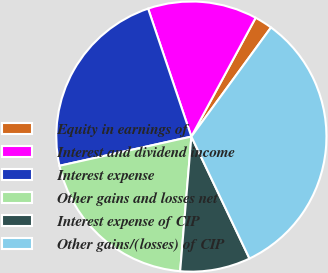Convert chart to OTSL. <chart><loc_0><loc_0><loc_500><loc_500><pie_chart><fcel>Equity in earnings of<fcel>Interest and dividend income<fcel>Interest expense<fcel>Other gains and losses net<fcel>Interest expense of CIP<fcel>Other gains/(losses) of CIP<nl><fcel>2.14%<fcel>13.08%<fcel>23.28%<fcel>20.21%<fcel>8.4%<fcel>32.89%<nl></chart> 